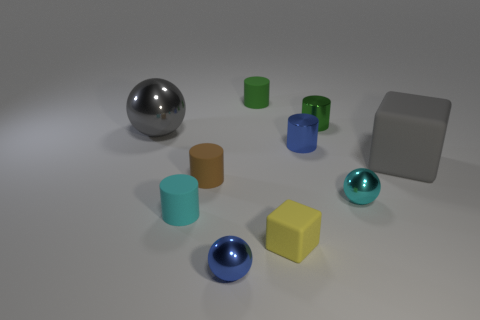What number of things are rubber things that are to the left of the gray rubber block or large gray objects to the right of the large ball?
Give a very brief answer. 5. There is a green matte object that is the same size as the blue sphere; what shape is it?
Provide a short and direct response. Cylinder. Is there another thing that has the same shape as the gray matte object?
Your answer should be very brief. Yes. Is the number of gray rubber blocks less than the number of rubber cylinders?
Your response must be concise. Yes. There is a cyan thing to the left of the cyan metal thing; is it the same size as the cyan object that is to the right of the tiny blue metal sphere?
Offer a terse response. Yes. What number of things are either big red rubber blocks or green things?
Offer a very short reply. 2. What is the size of the metal thing that is left of the small blue ball?
Your answer should be compact. Large. There is a big gray thing that is right of the tiny cyan matte thing that is left of the brown matte cylinder; what number of green matte things are in front of it?
Ensure brevity in your answer.  0. Is the large rubber object the same color as the big sphere?
Provide a short and direct response. Yes. How many small metallic things are behind the large gray matte object and left of the tiny blue metallic cylinder?
Offer a terse response. 0. 